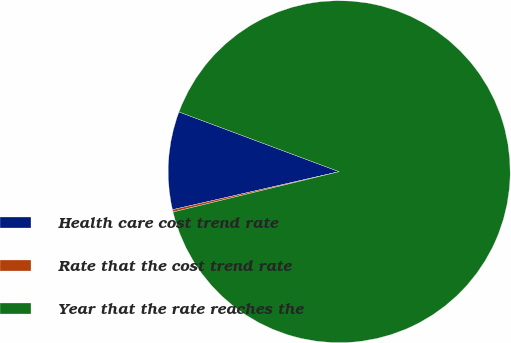Convert chart to OTSL. <chart><loc_0><loc_0><loc_500><loc_500><pie_chart><fcel>Health care cost trend rate<fcel>Rate that the cost trend rate<fcel>Year that the rate reaches the<nl><fcel>9.25%<fcel>0.22%<fcel>90.52%<nl></chart> 